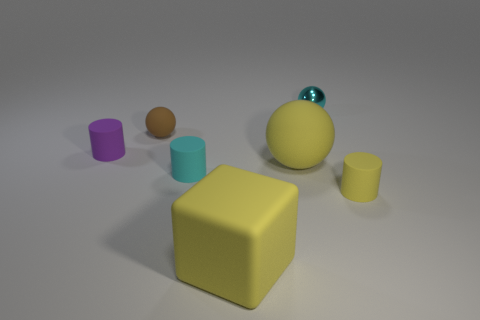Subtract all cyan rubber cylinders. How many cylinders are left? 2 Subtract all purple cylinders. How many cylinders are left? 2 Subtract all balls. How many objects are left? 4 Subtract 2 balls. How many balls are left? 1 Add 2 balls. How many objects exist? 9 Subtract all brown cylinders. Subtract all blue balls. How many cylinders are left? 3 Subtract all gray blocks. How many red cylinders are left? 0 Subtract all small cyan rubber cylinders. Subtract all tiny matte balls. How many objects are left? 5 Add 7 metal objects. How many metal objects are left? 8 Add 1 cyan matte cylinders. How many cyan matte cylinders exist? 2 